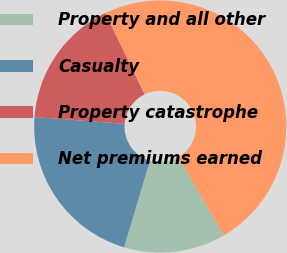Convert chart to OTSL. <chart><loc_0><loc_0><loc_500><loc_500><pie_chart><fcel>Property and all other<fcel>Casualty<fcel>Property catastrophe<fcel>Net premiums earned<nl><fcel>13.05%<fcel>21.57%<fcel>16.62%<fcel>48.76%<nl></chart> 